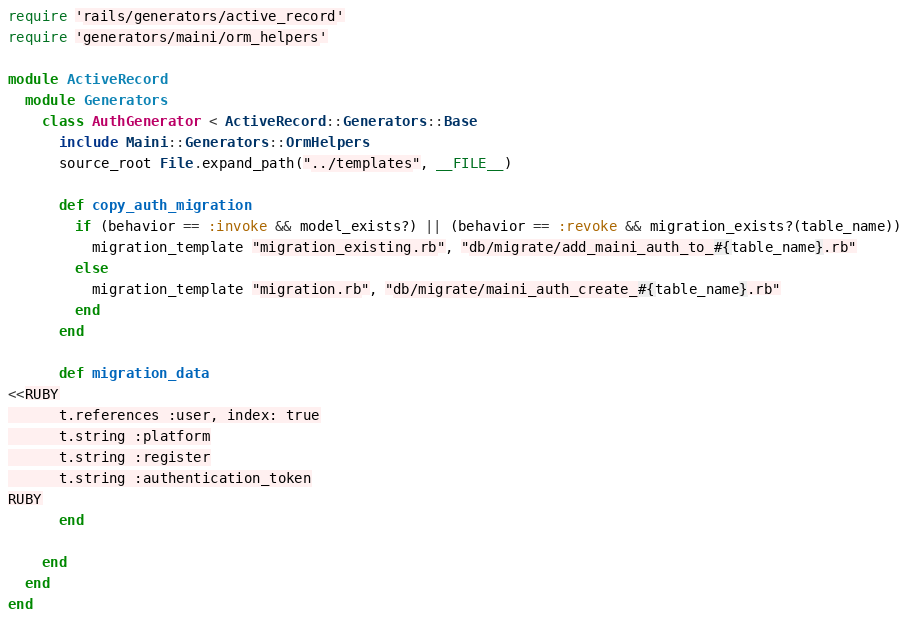Convert code to text. <code><loc_0><loc_0><loc_500><loc_500><_Ruby_>require 'rails/generators/active_record'
require 'generators/maini/orm_helpers'

module ActiveRecord
  module Generators
    class AuthGenerator < ActiveRecord::Generators::Base
      include Maini::Generators::OrmHelpers
      source_root File.expand_path("../templates", __FILE__)

      def copy_auth_migration
        if (behavior == :invoke && model_exists?) || (behavior == :revoke && migration_exists?(table_name))
          migration_template "migration_existing.rb", "db/migrate/add_maini_auth_to_#{table_name}.rb"
        else
          migration_template "migration.rb", "db/migrate/maini_auth_create_#{table_name}.rb"
        end
      end

      def migration_data
<<RUBY
      t.references :user, index: true
      t.string :platform
      t.string :register
      t.string :authentication_token
RUBY
      end

    end
  end
end
</code> 